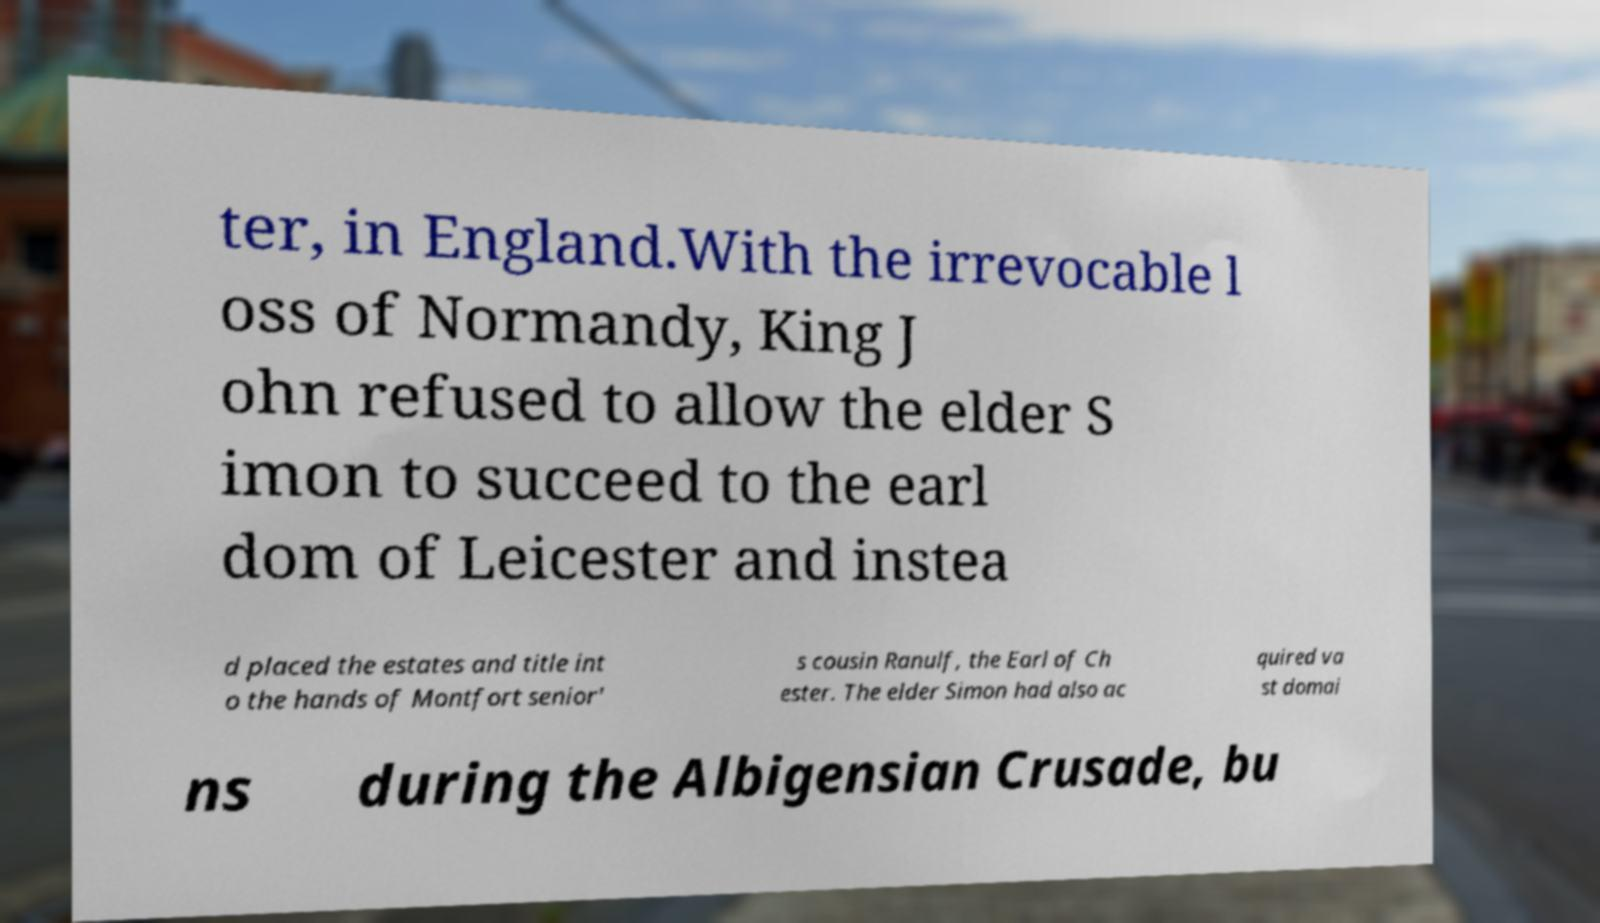What messages or text are displayed in this image? I need them in a readable, typed format. ter, in England.With the irrevocable l oss of Normandy, King J ohn refused to allow the elder S imon to succeed to the earl dom of Leicester and instea d placed the estates and title int o the hands of Montfort senior' s cousin Ranulf, the Earl of Ch ester. The elder Simon had also ac quired va st domai ns during the Albigensian Crusade, bu 